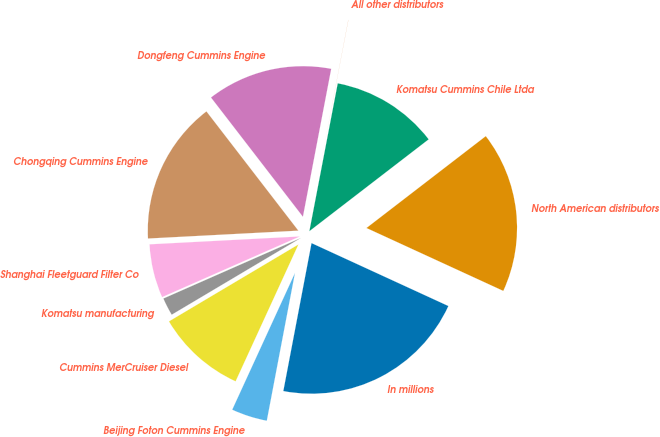Convert chart to OTSL. <chart><loc_0><loc_0><loc_500><loc_500><pie_chart><fcel>In millions<fcel>North American distributors<fcel>Komatsu Cummins Chile Ltda<fcel>All other distributors<fcel>Dongfeng Cummins Engine<fcel>Chongqing Cummins Engine<fcel>Shanghai Fleetguard Filter Co<fcel>Komatsu manufacturing<fcel>Cummins MerCruiser Diesel<fcel>Beijing Foton Cummins Engine<nl><fcel>21.14%<fcel>17.3%<fcel>11.54%<fcel>0.01%<fcel>13.46%<fcel>15.38%<fcel>5.77%<fcel>1.93%<fcel>9.62%<fcel>3.85%<nl></chart> 